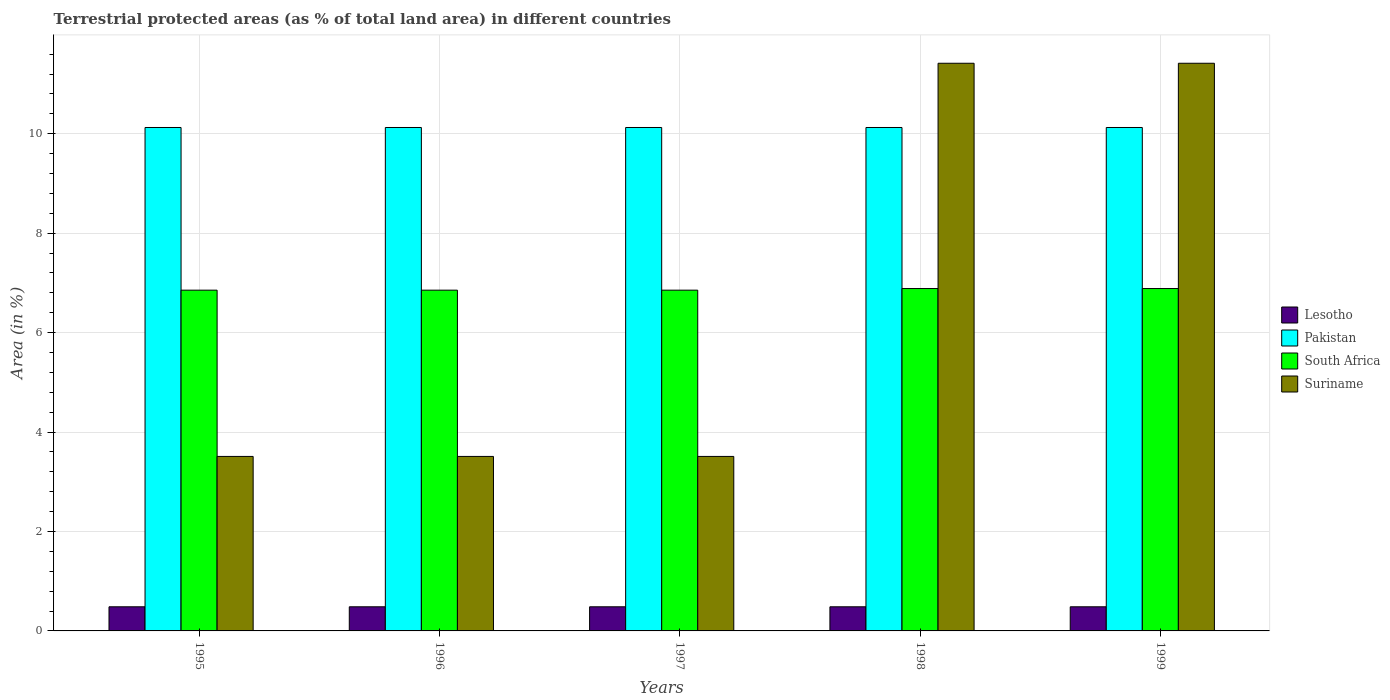How many bars are there on the 2nd tick from the right?
Provide a short and direct response. 4. What is the percentage of terrestrial protected land in Suriname in 1995?
Your response must be concise. 3.51. Across all years, what is the maximum percentage of terrestrial protected land in Pakistan?
Keep it short and to the point. 10.13. Across all years, what is the minimum percentage of terrestrial protected land in South Africa?
Ensure brevity in your answer.  6.85. In which year was the percentage of terrestrial protected land in Lesotho minimum?
Give a very brief answer. 1995. What is the total percentage of terrestrial protected land in Pakistan in the graph?
Offer a very short reply. 50.63. What is the difference between the percentage of terrestrial protected land in South Africa in 1999 and the percentage of terrestrial protected land in Lesotho in 1995?
Provide a short and direct response. 6.4. What is the average percentage of terrestrial protected land in Lesotho per year?
Keep it short and to the point. 0.49. In the year 1995, what is the difference between the percentage of terrestrial protected land in Pakistan and percentage of terrestrial protected land in Suriname?
Your answer should be very brief. 6.62. In how many years, is the percentage of terrestrial protected land in South Africa greater than 3.6 %?
Give a very brief answer. 5. What is the ratio of the percentage of terrestrial protected land in Suriname in 1995 to that in 1998?
Keep it short and to the point. 0.31. Is the percentage of terrestrial protected land in South Africa in 1995 less than that in 1999?
Your answer should be very brief. Yes. What is the difference between the highest and the second highest percentage of terrestrial protected land in Suriname?
Give a very brief answer. 0. Is it the case that in every year, the sum of the percentage of terrestrial protected land in Suriname and percentage of terrestrial protected land in Lesotho is greater than the sum of percentage of terrestrial protected land in South Africa and percentage of terrestrial protected land in Pakistan?
Offer a very short reply. No. What does the 4th bar from the left in 1995 represents?
Offer a very short reply. Suriname. Is it the case that in every year, the sum of the percentage of terrestrial protected land in Suriname and percentage of terrestrial protected land in Pakistan is greater than the percentage of terrestrial protected land in South Africa?
Offer a very short reply. Yes. Are all the bars in the graph horizontal?
Give a very brief answer. No. Are the values on the major ticks of Y-axis written in scientific E-notation?
Ensure brevity in your answer.  No. How many legend labels are there?
Keep it short and to the point. 4. What is the title of the graph?
Provide a succinct answer. Terrestrial protected areas (as % of total land area) in different countries. What is the label or title of the Y-axis?
Ensure brevity in your answer.  Area (in %). What is the Area (in %) in Lesotho in 1995?
Your answer should be compact. 0.49. What is the Area (in %) of Pakistan in 1995?
Make the answer very short. 10.13. What is the Area (in %) in South Africa in 1995?
Offer a very short reply. 6.85. What is the Area (in %) of Suriname in 1995?
Your response must be concise. 3.51. What is the Area (in %) of Lesotho in 1996?
Make the answer very short. 0.49. What is the Area (in %) of Pakistan in 1996?
Your answer should be very brief. 10.13. What is the Area (in %) of South Africa in 1996?
Give a very brief answer. 6.85. What is the Area (in %) in Suriname in 1996?
Your response must be concise. 3.51. What is the Area (in %) of Lesotho in 1997?
Offer a terse response. 0.49. What is the Area (in %) in Pakistan in 1997?
Provide a succinct answer. 10.13. What is the Area (in %) in South Africa in 1997?
Your answer should be compact. 6.85. What is the Area (in %) in Suriname in 1997?
Provide a short and direct response. 3.51. What is the Area (in %) of Lesotho in 1998?
Your response must be concise. 0.49. What is the Area (in %) of Pakistan in 1998?
Offer a terse response. 10.13. What is the Area (in %) of South Africa in 1998?
Provide a succinct answer. 6.89. What is the Area (in %) of Suriname in 1998?
Provide a short and direct response. 11.42. What is the Area (in %) of Lesotho in 1999?
Provide a short and direct response. 0.49. What is the Area (in %) of Pakistan in 1999?
Make the answer very short. 10.13. What is the Area (in %) of South Africa in 1999?
Offer a very short reply. 6.89. What is the Area (in %) of Suriname in 1999?
Offer a very short reply. 11.42. Across all years, what is the maximum Area (in %) in Lesotho?
Keep it short and to the point. 0.49. Across all years, what is the maximum Area (in %) in Pakistan?
Offer a very short reply. 10.13. Across all years, what is the maximum Area (in %) in South Africa?
Offer a very short reply. 6.89. Across all years, what is the maximum Area (in %) of Suriname?
Make the answer very short. 11.42. Across all years, what is the minimum Area (in %) of Lesotho?
Keep it short and to the point. 0.49. Across all years, what is the minimum Area (in %) in Pakistan?
Your answer should be very brief. 10.13. Across all years, what is the minimum Area (in %) in South Africa?
Offer a terse response. 6.85. Across all years, what is the minimum Area (in %) in Suriname?
Provide a short and direct response. 3.51. What is the total Area (in %) of Lesotho in the graph?
Provide a short and direct response. 2.43. What is the total Area (in %) of Pakistan in the graph?
Give a very brief answer. 50.63. What is the total Area (in %) in South Africa in the graph?
Give a very brief answer. 34.33. What is the total Area (in %) of Suriname in the graph?
Give a very brief answer. 33.36. What is the difference between the Area (in %) of Lesotho in 1995 and that in 1996?
Your response must be concise. 0. What is the difference between the Area (in %) in South Africa in 1995 and that in 1996?
Give a very brief answer. 0. What is the difference between the Area (in %) in Suriname in 1995 and that in 1996?
Give a very brief answer. 0. What is the difference between the Area (in %) in South Africa in 1995 and that in 1998?
Offer a terse response. -0.03. What is the difference between the Area (in %) in Suriname in 1995 and that in 1998?
Provide a succinct answer. -7.91. What is the difference between the Area (in %) of South Africa in 1995 and that in 1999?
Your answer should be very brief. -0.03. What is the difference between the Area (in %) of Suriname in 1995 and that in 1999?
Your answer should be compact. -7.91. What is the difference between the Area (in %) of Pakistan in 1996 and that in 1997?
Keep it short and to the point. 0. What is the difference between the Area (in %) in Suriname in 1996 and that in 1997?
Keep it short and to the point. 0. What is the difference between the Area (in %) of South Africa in 1996 and that in 1998?
Keep it short and to the point. -0.03. What is the difference between the Area (in %) of Suriname in 1996 and that in 1998?
Make the answer very short. -7.91. What is the difference between the Area (in %) of Lesotho in 1996 and that in 1999?
Keep it short and to the point. 0. What is the difference between the Area (in %) in Pakistan in 1996 and that in 1999?
Your response must be concise. 0. What is the difference between the Area (in %) of South Africa in 1996 and that in 1999?
Provide a succinct answer. -0.03. What is the difference between the Area (in %) in Suriname in 1996 and that in 1999?
Your answer should be compact. -7.91. What is the difference between the Area (in %) of Pakistan in 1997 and that in 1998?
Make the answer very short. 0. What is the difference between the Area (in %) in South Africa in 1997 and that in 1998?
Ensure brevity in your answer.  -0.03. What is the difference between the Area (in %) in Suriname in 1997 and that in 1998?
Your answer should be compact. -7.91. What is the difference between the Area (in %) in Pakistan in 1997 and that in 1999?
Provide a short and direct response. 0. What is the difference between the Area (in %) in South Africa in 1997 and that in 1999?
Provide a succinct answer. -0.03. What is the difference between the Area (in %) in Suriname in 1997 and that in 1999?
Provide a succinct answer. -7.91. What is the difference between the Area (in %) in South Africa in 1998 and that in 1999?
Ensure brevity in your answer.  0. What is the difference between the Area (in %) of Lesotho in 1995 and the Area (in %) of Pakistan in 1996?
Your response must be concise. -9.64. What is the difference between the Area (in %) in Lesotho in 1995 and the Area (in %) in South Africa in 1996?
Your answer should be compact. -6.37. What is the difference between the Area (in %) in Lesotho in 1995 and the Area (in %) in Suriname in 1996?
Your answer should be compact. -3.02. What is the difference between the Area (in %) in Pakistan in 1995 and the Area (in %) in South Africa in 1996?
Provide a succinct answer. 3.27. What is the difference between the Area (in %) of Pakistan in 1995 and the Area (in %) of Suriname in 1996?
Provide a short and direct response. 6.62. What is the difference between the Area (in %) in South Africa in 1995 and the Area (in %) in Suriname in 1996?
Make the answer very short. 3.34. What is the difference between the Area (in %) of Lesotho in 1995 and the Area (in %) of Pakistan in 1997?
Keep it short and to the point. -9.64. What is the difference between the Area (in %) in Lesotho in 1995 and the Area (in %) in South Africa in 1997?
Make the answer very short. -6.37. What is the difference between the Area (in %) in Lesotho in 1995 and the Area (in %) in Suriname in 1997?
Ensure brevity in your answer.  -3.02. What is the difference between the Area (in %) of Pakistan in 1995 and the Area (in %) of South Africa in 1997?
Ensure brevity in your answer.  3.27. What is the difference between the Area (in %) in Pakistan in 1995 and the Area (in %) in Suriname in 1997?
Your answer should be compact. 6.62. What is the difference between the Area (in %) of South Africa in 1995 and the Area (in %) of Suriname in 1997?
Your answer should be compact. 3.34. What is the difference between the Area (in %) in Lesotho in 1995 and the Area (in %) in Pakistan in 1998?
Your answer should be compact. -9.64. What is the difference between the Area (in %) in Lesotho in 1995 and the Area (in %) in South Africa in 1998?
Your answer should be very brief. -6.4. What is the difference between the Area (in %) in Lesotho in 1995 and the Area (in %) in Suriname in 1998?
Keep it short and to the point. -10.93. What is the difference between the Area (in %) in Pakistan in 1995 and the Area (in %) in South Africa in 1998?
Offer a terse response. 3.24. What is the difference between the Area (in %) of Pakistan in 1995 and the Area (in %) of Suriname in 1998?
Give a very brief answer. -1.29. What is the difference between the Area (in %) of South Africa in 1995 and the Area (in %) of Suriname in 1998?
Ensure brevity in your answer.  -4.56. What is the difference between the Area (in %) in Lesotho in 1995 and the Area (in %) in Pakistan in 1999?
Provide a short and direct response. -9.64. What is the difference between the Area (in %) of Lesotho in 1995 and the Area (in %) of South Africa in 1999?
Give a very brief answer. -6.4. What is the difference between the Area (in %) in Lesotho in 1995 and the Area (in %) in Suriname in 1999?
Offer a terse response. -10.93. What is the difference between the Area (in %) in Pakistan in 1995 and the Area (in %) in South Africa in 1999?
Offer a very short reply. 3.24. What is the difference between the Area (in %) of Pakistan in 1995 and the Area (in %) of Suriname in 1999?
Provide a succinct answer. -1.29. What is the difference between the Area (in %) in South Africa in 1995 and the Area (in %) in Suriname in 1999?
Keep it short and to the point. -4.56. What is the difference between the Area (in %) of Lesotho in 1996 and the Area (in %) of Pakistan in 1997?
Your answer should be compact. -9.64. What is the difference between the Area (in %) in Lesotho in 1996 and the Area (in %) in South Africa in 1997?
Give a very brief answer. -6.37. What is the difference between the Area (in %) of Lesotho in 1996 and the Area (in %) of Suriname in 1997?
Provide a succinct answer. -3.02. What is the difference between the Area (in %) in Pakistan in 1996 and the Area (in %) in South Africa in 1997?
Make the answer very short. 3.27. What is the difference between the Area (in %) in Pakistan in 1996 and the Area (in %) in Suriname in 1997?
Give a very brief answer. 6.62. What is the difference between the Area (in %) of South Africa in 1996 and the Area (in %) of Suriname in 1997?
Ensure brevity in your answer.  3.34. What is the difference between the Area (in %) in Lesotho in 1996 and the Area (in %) in Pakistan in 1998?
Your answer should be compact. -9.64. What is the difference between the Area (in %) in Lesotho in 1996 and the Area (in %) in South Africa in 1998?
Provide a succinct answer. -6.4. What is the difference between the Area (in %) of Lesotho in 1996 and the Area (in %) of Suriname in 1998?
Your answer should be very brief. -10.93. What is the difference between the Area (in %) of Pakistan in 1996 and the Area (in %) of South Africa in 1998?
Ensure brevity in your answer.  3.24. What is the difference between the Area (in %) of Pakistan in 1996 and the Area (in %) of Suriname in 1998?
Make the answer very short. -1.29. What is the difference between the Area (in %) in South Africa in 1996 and the Area (in %) in Suriname in 1998?
Offer a terse response. -4.56. What is the difference between the Area (in %) of Lesotho in 1996 and the Area (in %) of Pakistan in 1999?
Give a very brief answer. -9.64. What is the difference between the Area (in %) of Lesotho in 1996 and the Area (in %) of South Africa in 1999?
Your answer should be very brief. -6.4. What is the difference between the Area (in %) of Lesotho in 1996 and the Area (in %) of Suriname in 1999?
Ensure brevity in your answer.  -10.93. What is the difference between the Area (in %) in Pakistan in 1996 and the Area (in %) in South Africa in 1999?
Ensure brevity in your answer.  3.24. What is the difference between the Area (in %) of Pakistan in 1996 and the Area (in %) of Suriname in 1999?
Keep it short and to the point. -1.29. What is the difference between the Area (in %) in South Africa in 1996 and the Area (in %) in Suriname in 1999?
Your answer should be very brief. -4.56. What is the difference between the Area (in %) of Lesotho in 1997 and the Area (in %) of Pakistan in 1998?
Give a very brief answer. -9.64. What is the difference between the Area (in %) in Lesotho in 1997 and the Area (in %) in South Africa in 1998?
Offer a terse response. -6.4. What is the difference between the Area (in %) of Lesotho in 1997 and the Area (in %) of Suriname in 1998?
Your answer should be compact. -10.93. What is the difference between the Area (in %) of Pakistan in 1997 and the Area (in %) of South Africa in 1998?
Provide a short and direct response. 3.24. What is the difference between the Area (in %) of Pakistan in 1997 and the Area (in %) of Suriname in 1998?
Provide a short and direct response. -1.29. What is the difference between the Area (in %) in South Africa in 1997 and the Area (in %) in Suriname in 1998?
Keep it short and to the point. -4.56. What is the difference between the Area (in %) in Lesotho in 1997 and the Area (in %) in Pakistan in 1999?
Provide a short and direct response. -9.64. What is the difference between the Area (in %) of Lesotho in 1997 and the Area (in %) of South Africa in 1999?
Your response must be concise. -6.4. What is the difference between the Area (in %) in Lesotho in 1997 and the Area (in %) in Suriname in 1999?
Your answer should be compact. -10.93. What is the difference between the Area (in %) in Pakistan in 1997 and the Area (in %) in South Africa in 1999?
Offer a very short reply. 3.24. What is the difference between the Area (in %) of Pakistan in 1997 and the Area (in %) of Suriname in 1999?
Your answer should be compact. -1.29. What is the difference between the Area (in %) in South Africa in 1997 and the Area (in %) in Suriname in 1999?
Give a very brief answer. -4.56. What is the difference between the Area (in %) of Lesotho in 1998 and the Area (in %) of Pakistan in 1999?
Offer a terse response. -9.64. What is the difference between the Area (in %) in Lesotho in 1998 and the Area (in %) in South Africa in 1999?
Ensure brevity in your answer.  -6.4. What is the difference between the Area (in %) of Lesotho in 1998 and the Area (in %) of Suriname in 1999?
Provide a succinct answer. -10.93. What is the difference between the Area (in %) in Pakistan in 1998 and the Area (in %) in South Africa in 1999?
Your response must be concise. 3.24. What is the difference between the Area (in %) of Pakistan in 1998 and the Area (in %) of Suriname in 1999?
Your answer should be compact. -1.29. What is the difference between the Area (in %) in South Africa in 1998 and the Area (in %) in Suriname in 1999?
Ensure brevity in your answer.  -4.53. What is the average Area (in %) of Lesotho per year?
Keep it short and to the point. 0.49. What is the average Area (in %) in Pakistan per year?
Ensure brevity in your answer.  10.13. What is the average Area (in %) of South Africa per year?
Your response must be concise. 6.87. What is the average Area (in %) in Suriname per year?
Ensure brevity in your answer.  6.67. In the year 1995, what is the difference between the Area (in %) in Lesotho and Area (in %) in Pakistan?
Offer a terse response. -9.64. In the year 1995, what is the difference between the Area (in %) of Lesotho and Area (in %) of South Africa?
Make the answer very short. -6.37. In the year 1995, what is the difference between the Area (in %) in Lesotho and Area (in %) in Suriname?
Offer a very short reply. -3.02. In the year 1995, what is the difference between the Area (in %) in Pakistan and Area (in %) in South Africa?
Your answer should be compact. 3.27. In the year 1995, what is the difference between the Area (in %) of Pakistan and Area (in %) of Suriname?
Your response must be concise. 6.62. In the year 1995, what is the difference between the Area (in %) in South Africa and Area (in %) in Suriname?
Your response must be concise. 3.34. In the year 1996, what is the difference between the Area (in %) of Lesotho and Area (in %) of Pakistan?
Keep it short and to the point. -9.64. In the year 1996, what is the difference between the Area (in %) of Lesotho and Area (in %) of South Africa?
Make the answer very short. -6.37. In the year 1996, what is the difference between the Area (in %) of Lesotho and Area (in %) of Suriname?
Give a very brief answer. -3.02. In the year 1996, what is the difference between the Area (in %) in Pakistan and Area (in %) in South Africa?
Provide a short and direct response. 3.27. In the year 1996, what is the difference between the Area (in %) of Pakistan and Area (in %) of Suriname?
Provide a succinct answer. 6.62. In the year 1996, what is the difference between the Area (in %) of South Africa and Area (in %) of Suriname?
Your answer should be compact. 3.34. In the year 1997, what is the difference between the Area (in %) in Lesotho and Area (in %) in Pakistan?
Your answer should be very brief. -9.64. In the year 1997, what is the difference between the Area (in %) of Lesotho and Area (in %) of South Africa?
Give a very brief answer. -6.37. In the year 1997, what is the difference between the Area (in %) of Lesotho and Area (in %) of Suriname?
Your answer should be very brief. -3.02. In the year 1997, what is the difference between the Area (in %) of Pakistan and Area (in %) of South Africa?
Make the answer very short. 3.27. In the year 1997, what is the difference between the Area (in %) of Pakistan and Area (in %) of Suriname?
Provide a succinct answer. 6.62. In the year 1997, what is the difference between the Area (in %) of South Africa and Area (in %) of Suriname?
Make the answer very short. 3.34. In the year 1998, what is the difference between the Area (in %) of Lesotho and Area (in %) of Pakistan?
Ensure brevity in your answer.  -9.64. In the year 1998, what is the difference between the Area (in %) in Lesotho and Area (in %) in South Africa?
Your response must be concise. -6.4. In the year 1998, what is the difference between the Area (in %) of Lesotho and Area (in %) of Suriname?
Provide a short and direct response. -10.93. In the year 1998, what is the difference between the Area (in %) of Pakistan and Area (in %) of South Africa?
Keep it short and to the point. 3.24. In the year 1998, what is the difference between the Area (in %) of Pakistan and Area (in %) of Suriname?
Your answer should be very brief. -1.29. In the year 1998, what is the difference between the Area (in %) in South Africa and Area (in %) in Suriname?
Your answer should be compact. -4.53. In the year 1999, what is the difference between the Area (in %) of Lesotho and Area (in %) of Pakistan?
Keep it short and to the point. -9.64. In the year 1999, what is the difference between the Area (in %) of Lesotho and Area (in %) of South Africa?
Your answer should be compact. -6.4. In the year 1999, what is the difference between the Area (in %) of Lesotho and Area (in %) of Suriname?
Give a very brief answer. -10.93. In the year 1999, what is the difference between the Area (in %) of Pakistan and Area (in %) of South Africa?
Provide a succinct answer. 3.24. In the year 1999, what is the difference between the Area (in %) of Pakistan and Area (in %) of Suriname?
Ensure brevity in your answer.  -1.29. In the year 1999, what is the difference between the Area (in %) of South Africa and Area (in %) of Suriname?
Your answer should be very brief. -4.53. What is the ratio of the Area (in %) in Lesotho in 1995 to that in 1996?
Your response must be concise. 1. What is the ratio of the Area (in %) of Pakistan in 1995 to that in 1996?
Your response must be concise. 1. What is the ratio of the Area (in %) in South Africa in 1995 to that in 1996?
Keep it short and to the point. 1. What is the ratio of the Area (in %) of Lesotho in 1995 to that in 1997?
Offer a very short reply. 1. What is the ratio of the Area (in %) in Suriname in 1995 to that in 1997?
Your answer should be compact. 1. What is the ratio of the Area (in %) of Lesotho in 1995 to that in 1998?
Keep it short and to the point. 1. What is the ratio of the Area (in %) of South Africa in 1995 to that in 1998?
Ensure brevity in your answer.  1. What is the ratio of the Area (in %) of Suriname in 1995 to that in 1998?
Provide a succinct answer. 0.31. What is the ratio of the Area (in %) in Lesotho in 1995 to that in 1999?
Provide a short and direct response. 1. What is the ratio of the Area (in %) in Suriname in 1995 to that in 1999?
Give a very brief answer. 0.31. What is the ratio of the Area (in %) of Suriname in 1996 to that in 1997?
Give a very brief answer. 1. What is the ratio of the Area (in %) of Pakistan in 1996 to that in 1998?
Give a very brief answer. 1. What is the ratio of the Area (in %) of South Africa in 1996 to that in 1998?
Ensure brevity in your answer.  1. What is the ratio of the Area (in %) in Suriname in 1996 to that in 1998?
Make the answer very short. 0.31. What is the ratio of the Area (in %) of Lesotho in 1996 to that in 1999?
Give a very brief answer. 1. What is the ratio of the Area (in %) of Pakistan in 1996 to that in 1999?
Make the answer very short. 1. What is the ratio of the Area (in %) in South Africa in 1996 to that in 1999?
Your answer should be very brief. 1. What is the ratio of the Area (in %) in Suriname in 1996 to that in 1999?
Your answer should be very brief. 0.31. What is the ratio of the Area (in %) in Lesotho in 1997 to that in 1998?
Provide a short and direct response. 1. What is the ratio of the Area (in %) of South Africa in 1997 to that in 1998?
Provide a short and direct response. 1. What is the ratio of the Area (in %) of Suriname in 1997 to that in 1998?
Offer a terse response. 0.31. What is the ratio of the Area (in %) in Suriname in 1997 to that in 1999?
Your answer should be compact. 0.31. What is the ratio of the Area (in %) of Lesotho in 1998 to that in 1999?
Offer a terse response. 1. What is the ratio of the Area (in %) in Suriname in 1998 to that in 1999?
Provide a short and direct response. 1. What is the difference between the highest and the second highest Area (in %) of Lesotho?
Provide a succinct answer. 0. What is the difference between the highest and the second highest Area (in %) of South Africa?
Ensure brevity in your answer.  0. What is the difference between the highest and the lowest Area (in %) in South Africa?
Make the answer very short. 0.03. What is the difference between the highest and the lowest Area (in %) of Suriname?
Offer a very short reply. 7.91. 